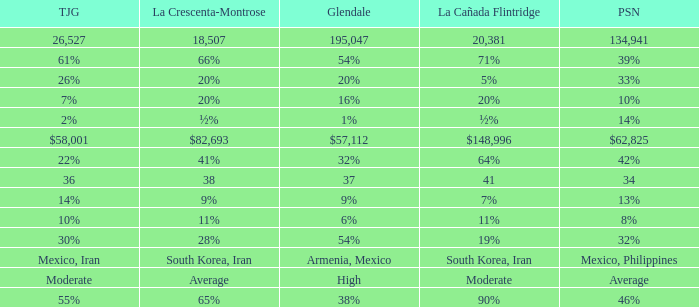What is the percentage of La Canada Flintridge when Tujunga is 7%? 20%. 